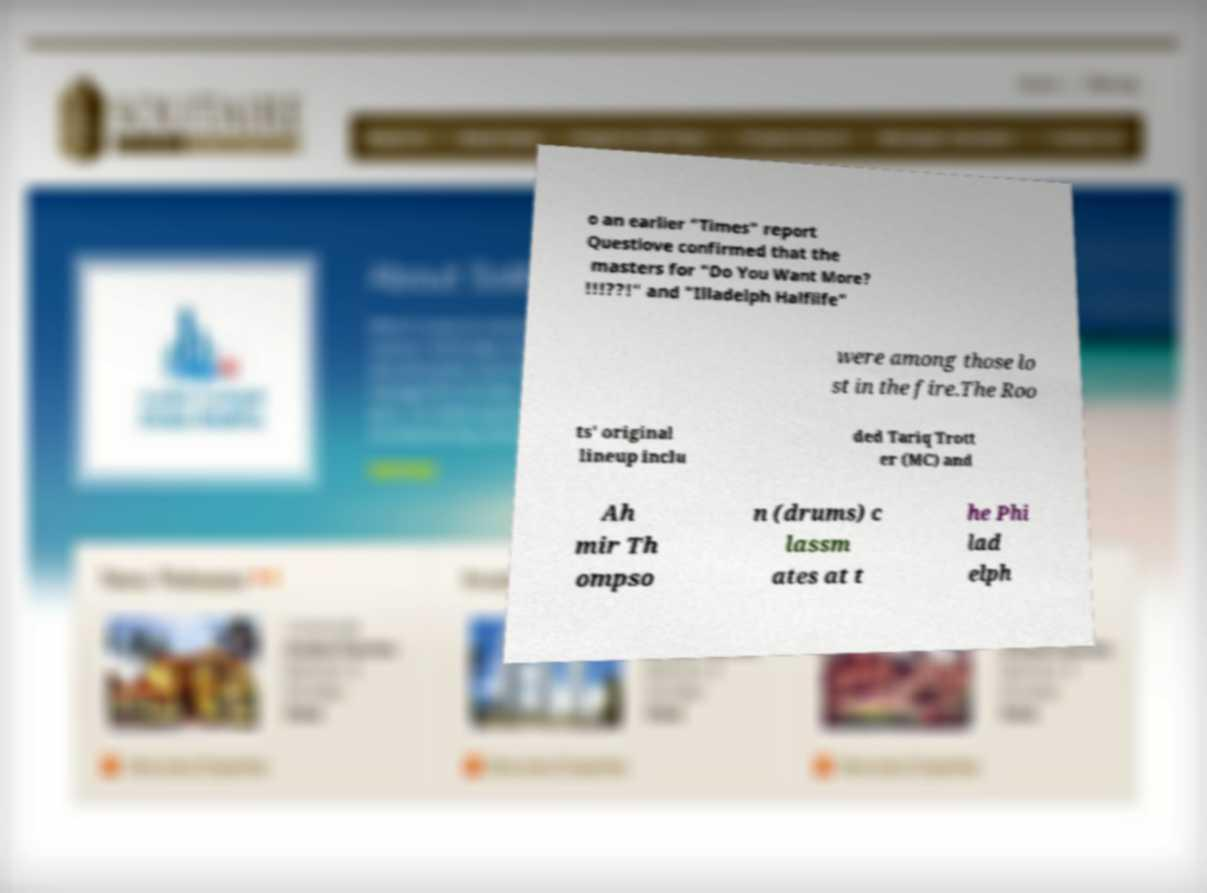For documentation purposes, I need the text within this image transcribed. Could you provide that? o an earlier "Times" report Questlove confirmed that the masters for "Do You Want More? !!!??!" and "Illadelph Halflife" were among those lo st in the fire.The Roo ts' original lineup inclu ded Tariq Trott er (MC) and Ah mir Th ompso n (drums) c lassm ates at t he Phi lad elph 